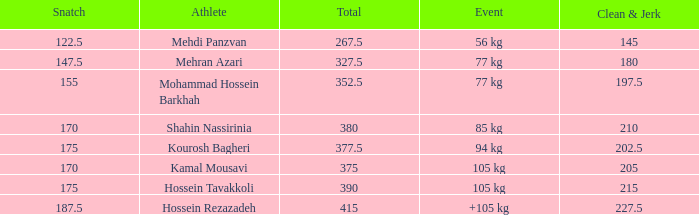Help me parse the entirety of this table. {'header': ['Snatch', 'Athlete', 'Total', 'Event', 'Clean & Jerk'], 'rows': [['122.5', 'Mehdi Panzvan', '267.5', '56 kg', '145'], ['147.5', 'Mehran Azari', '327.5', '77 kg', '180'], ['155', 'Mohammad Hossein Barkhah', '352.5', '77 kg', '197.5'], ['170', 'Shahin Nassirinia', '380', '85 kg', '210'], ['175', 'Kourosh Bagheri', '377.5', '94 kg', '202.5'], ['170', 'Kamal Mousavi', '375', '105 kg', '205'], ['175', 'Hossein Tavakkoli', '390', '105 kg', '215'], ['187.5', 'Hossein Rezazadeh', '415', '+105 kg', '227.5']]} What event has a 122.5 snatch rate? 56 kg. 